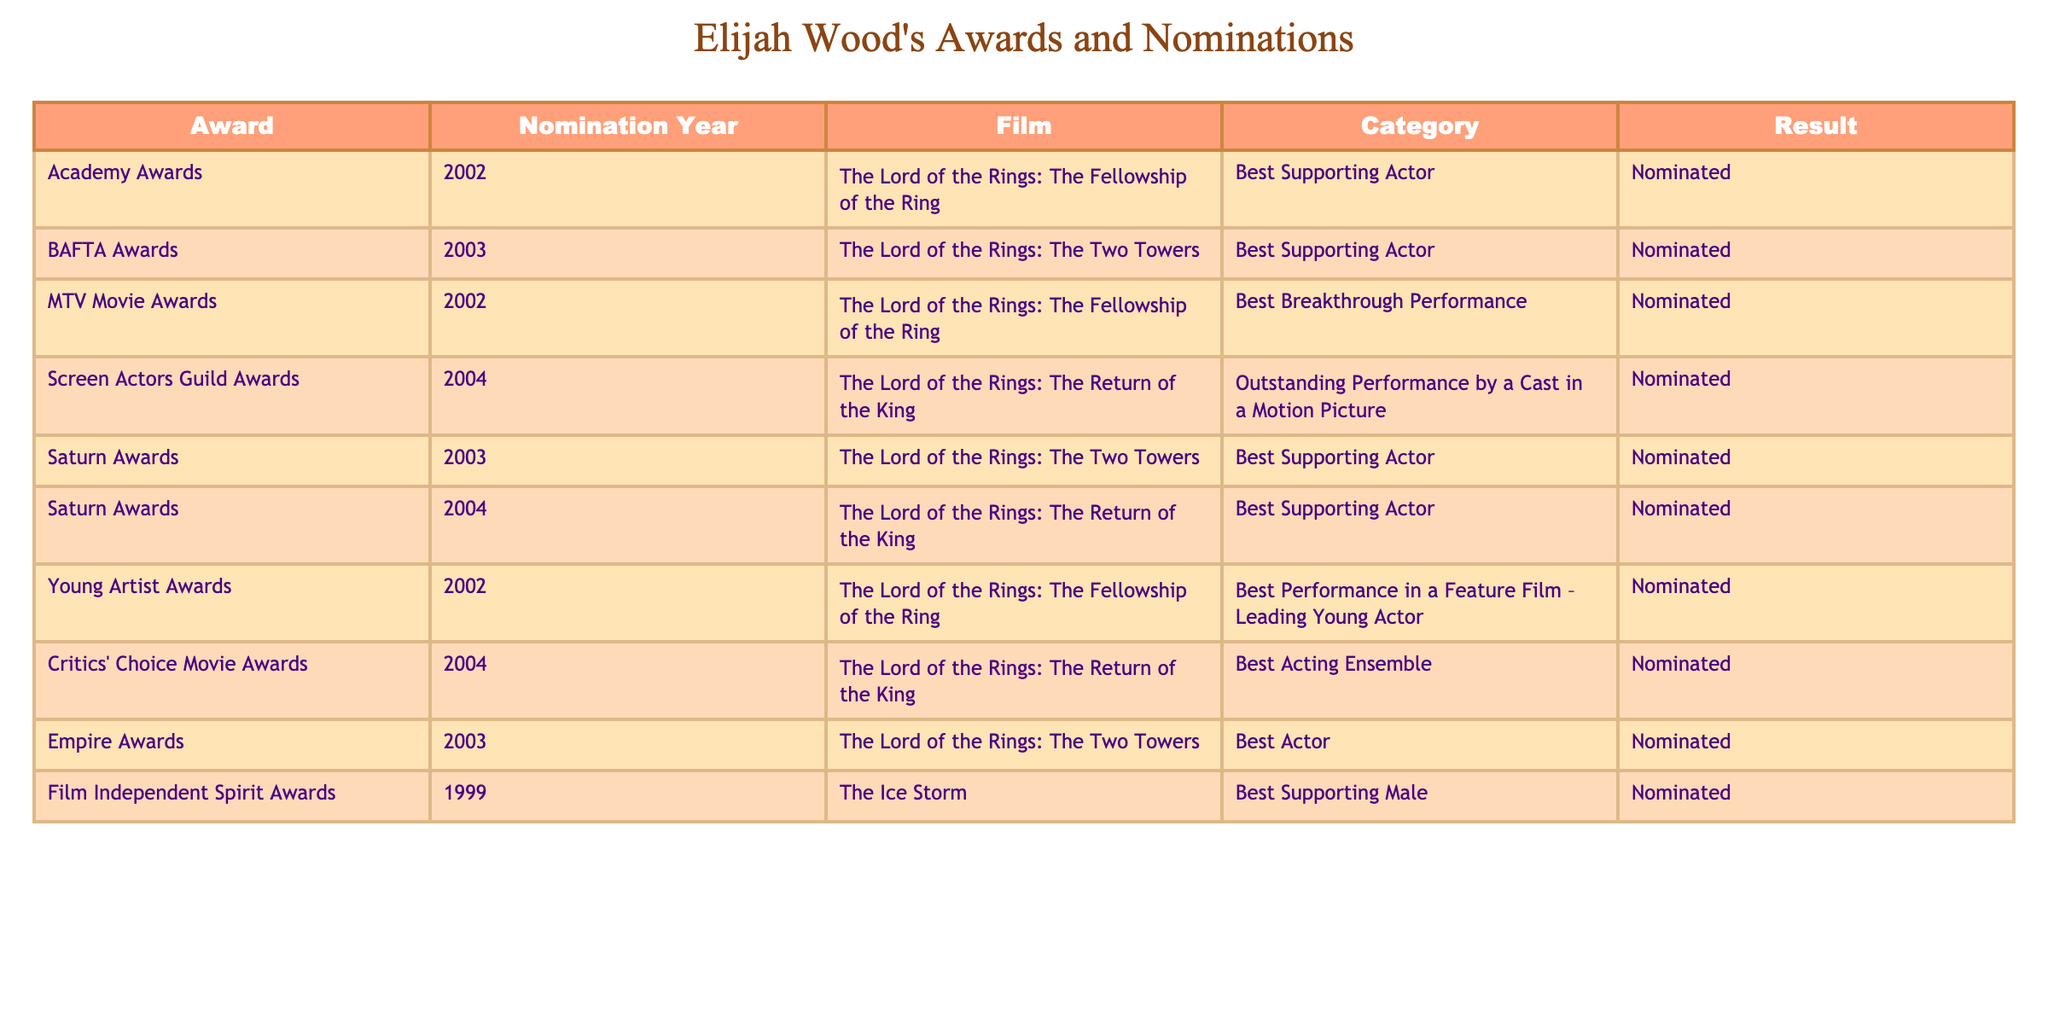What award did Elijah Wood receive a nomination for in 2002? In the table, under the 'Nomination Year' column, I look for the year 2002. The corresponding film is "The Lord of the Rings: The Fellowship of the Ring," and the 'Award' column indicates that he was nominated for the 'Best Supporting Actor' category.
Answer: Best Supporting Actor How many times was Elijah Wood nominated for an award in "The Lord of the Rings" series? I will count the number of nominations in the rows that contain "The Lord of the Rings" in the 'Film' column. There are five entries: 2002, 2003 (twice), and 2004 (twice). Therefore, he was nominated five times.
Answer: Five times Which film received the most nominations for Elijah Wood? By analyzing the 'Film' column, I find that "The Lord of the Rings: The Two Towers" appears twice (for the BAFTA Awards and the Saturn Awards), while "The Lord of the Rings: The Return of the King" also appears twice (for the Screen Actors Guild Awards and the Saturn Awards). "The Lord of the Rings: The Fellowship of the Ring" appears three times; hence, it received the most nominations.
Answer: The Lord of the Rings: The Fellowship of the Ring Did Elijah Wood win any awards listed in the table? A quick check of the 'Result' column reveals that all entries show 'Nominated,' which indicates he did not win any award listed in the table.
Answer: No Which award category has the most nominations listed for Elijah Wood? To find this, I will review the 'Category' column for overlaps. The 'Best Supporting Actor' category appears three times across different awards. The 'Nominated' statuses do not contribute to additional unique counts in other categories; thus, 'Best Supporting Actor' is the most frequent.
Answer: Best Supporting Actor 